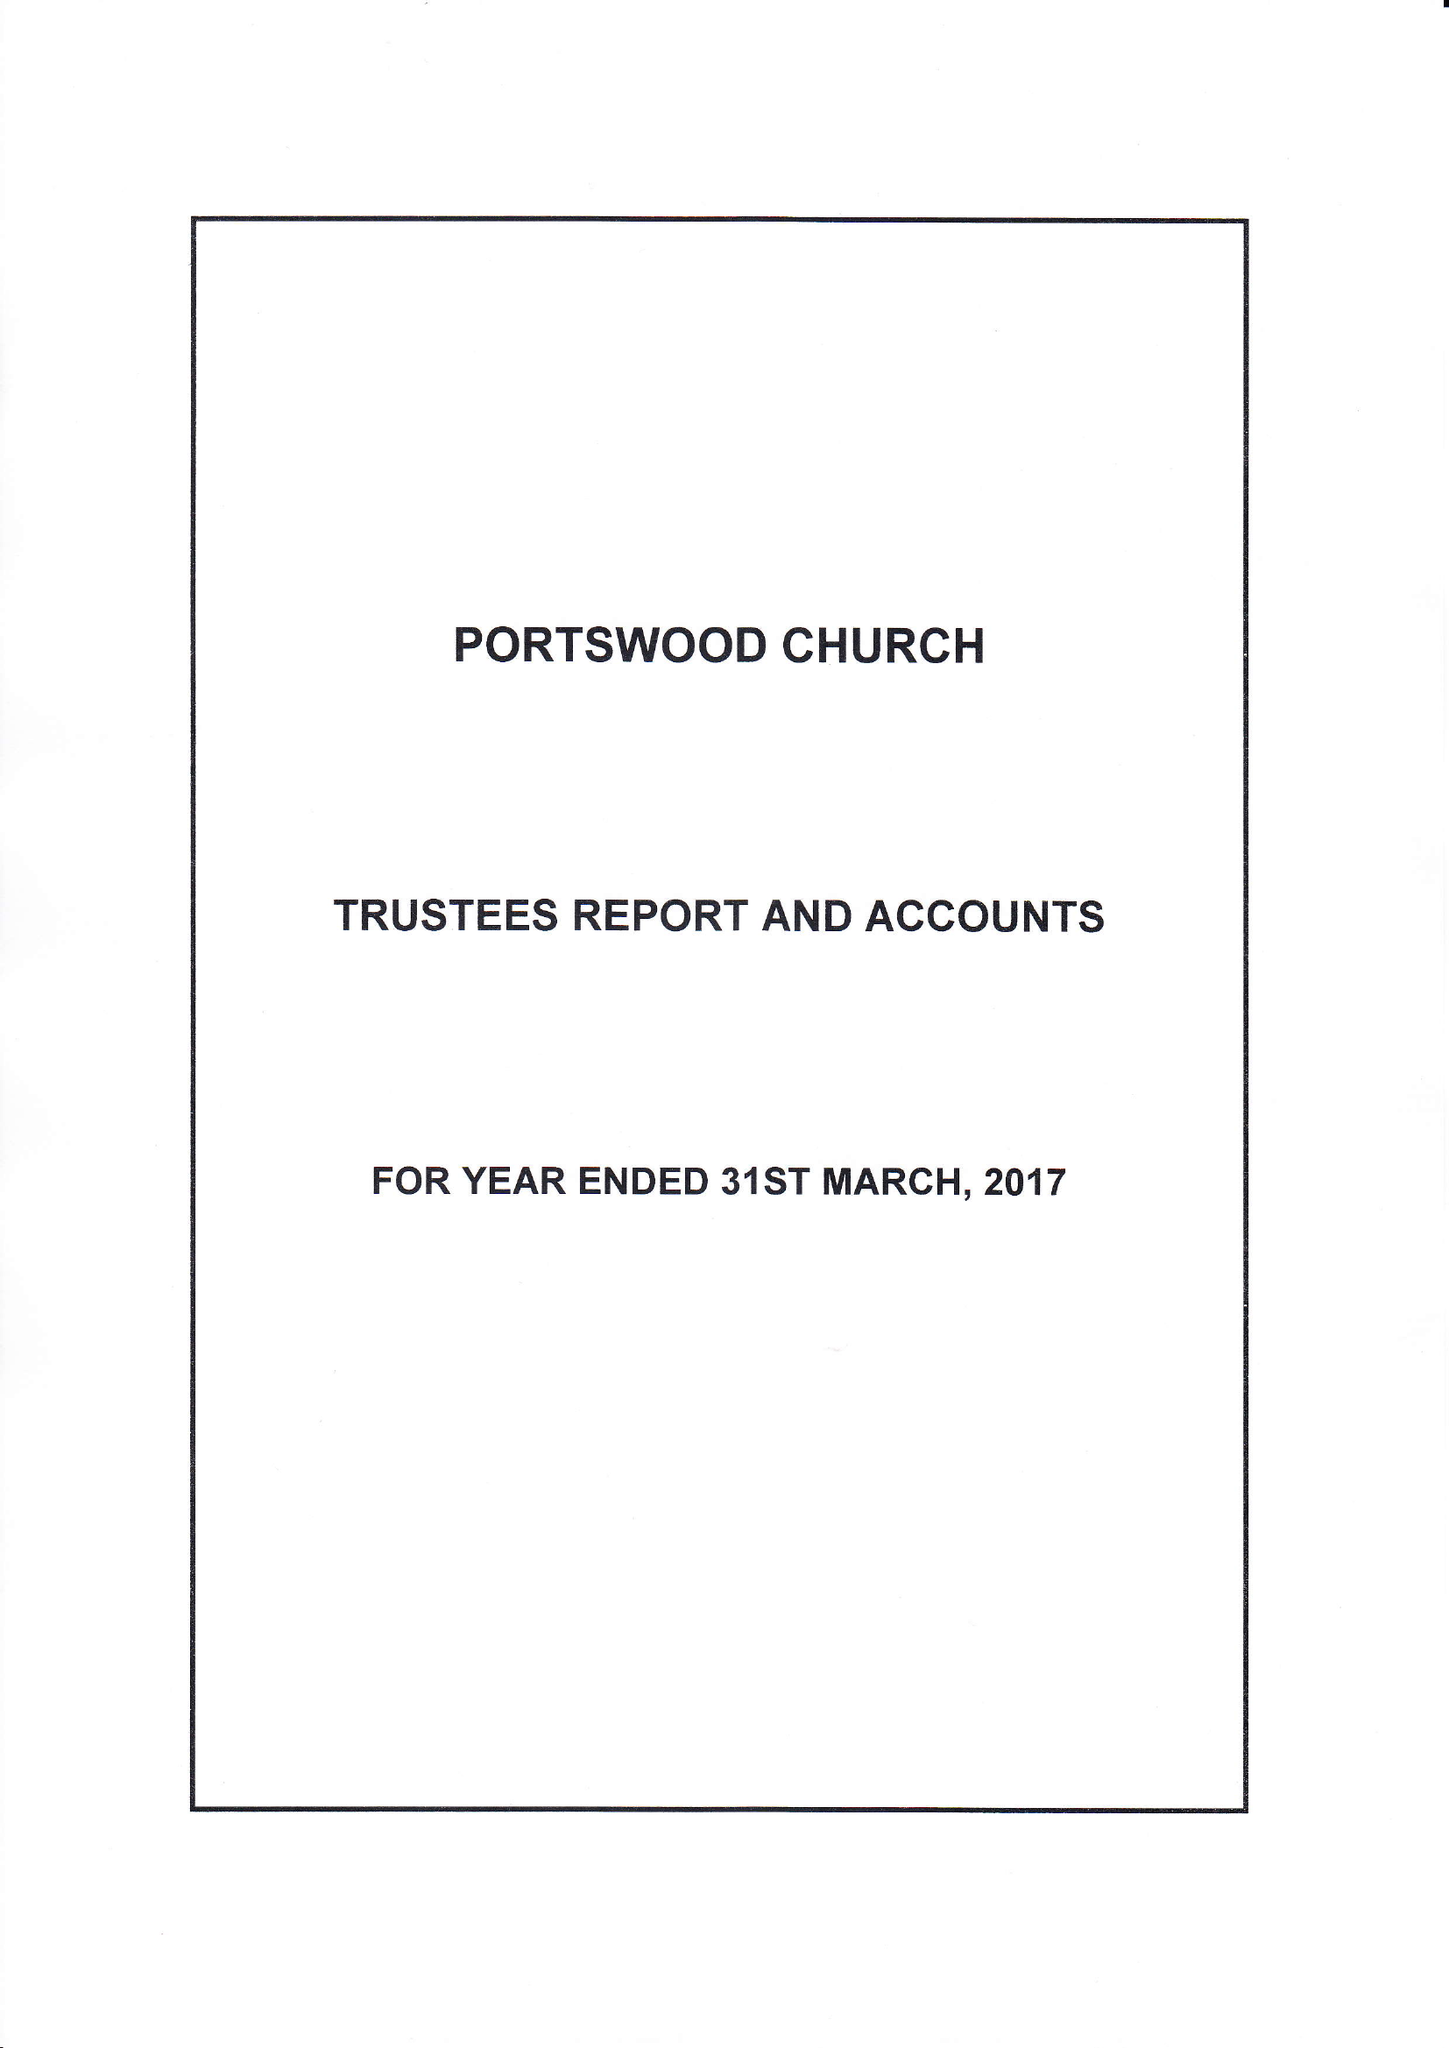What is the value for the address__postcode?
Answer the question using a single word or phrase. SO17 2FY 